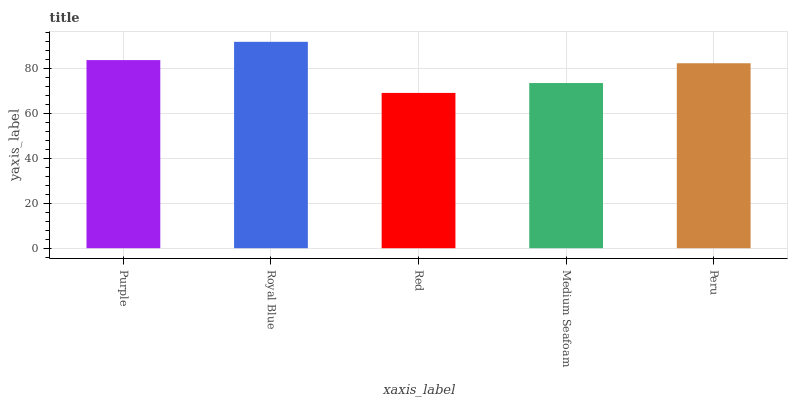Is Red the minimum?
Answer yes or no. Yes. Is Royal Blue the maximum?
Answer yes or no. Yes. Is Royal Blue the minimum?
Answer yes or no. No. Is Red the maximum?
Answer yes or no. No. Is Royal Blue greater than Red?
Answer yes or no. Yes. Is Red less than Royal Blue?
Answer yes or no. Yes. Is Red greater than Royal Blue?
Answer yes or no. No. Is Royal Blue less than Red?
Answer yes or no. No. Is Peru the high median?
Answer yes or no. Yes. Is Peru the low median?
Answer yes or no. Yes. Is Royal Blue the high median?
Answer yes or no. No. Is Medium Seafoam the low median?
Answer yes or no. No. 